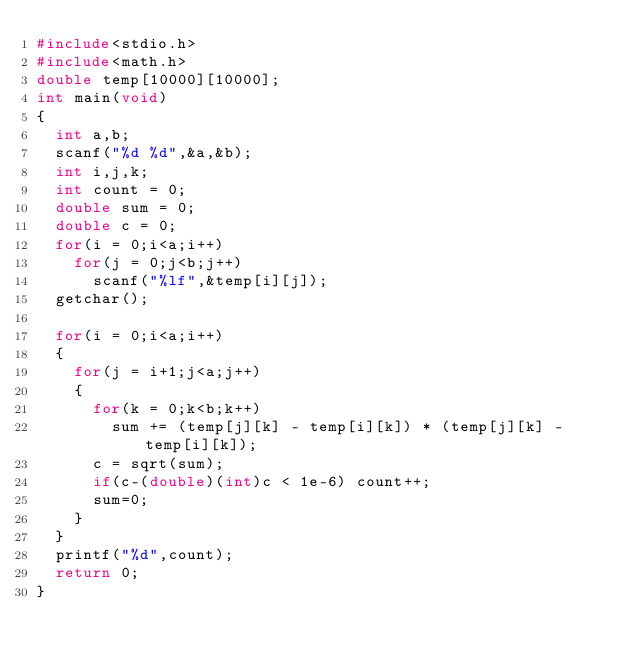Convert code to text. <code><loc_0><loc_0><loc_500><loc_500><_C_>#include<stdio.h>
#include<math.h>
double temp[10000][10000];
int main(void)
{
	int a,b;
	scanf("%d %d",&a,&b);
	int i,j,k;
	int count = 0;
	double sum = 0;
	double c = 0;
	for(i = 0;i<a;i++)
		for(j = 0;j<b;j++)
			scanf("%lf",&temp[i][j]);
	getchar(); 
	
	for(i = 0;i<a;i++)
	{
		for(j = i+1;j<a;j++)
		{
			for(k = 0;k<b;k++)
				sum += (temp[j][k] - temp[i][k]) * (temp[j][k] - temp[i][k]);
			c = sqrt(sum);
			if(c-(double)(int)c < 1e-6) count++;
			sum=0;
		}
	} 
	printf("%d",count);
	return 0;
}</code> 